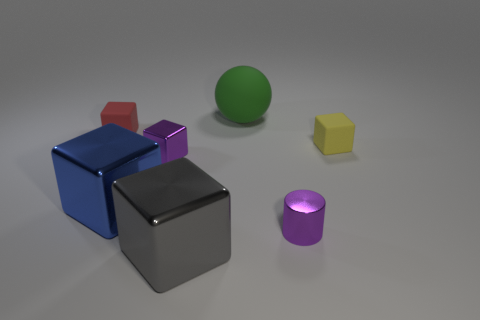Can you describe the colors of the objects in the image? Certainly! The image features objects with a variety of colors. There is a large blue block, a smaller purple block, a red block, a green sphere, a yellow hexagon, and a gray metal-looking cube in the foreground. 